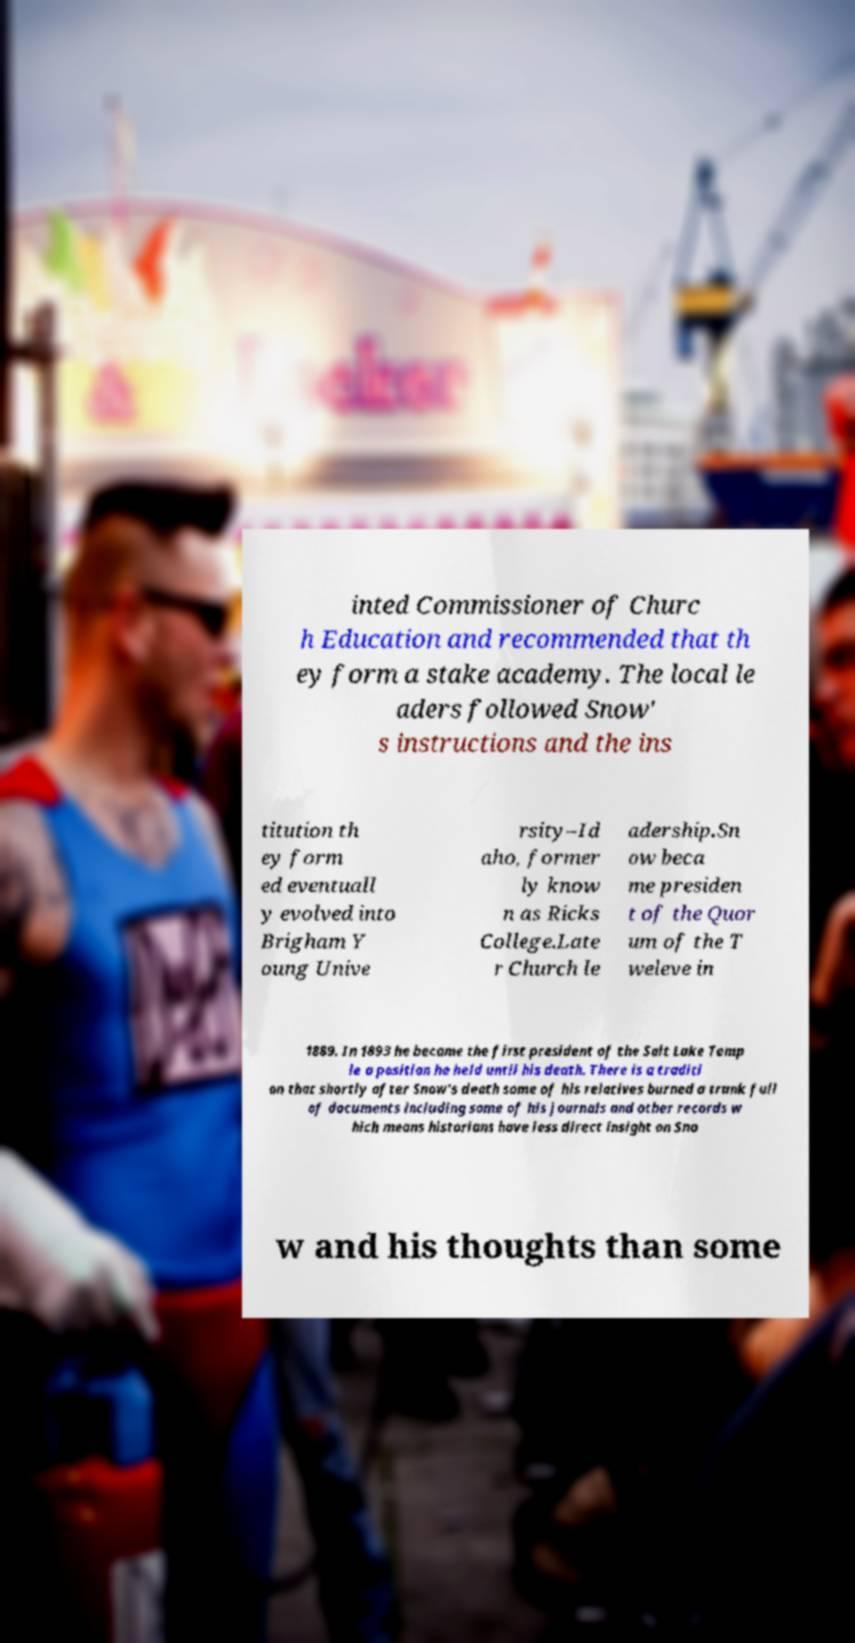Could you assist in decoding the text presented in this image and type it out clearly? inted Commissioner of Churc h Education and recommended that th ey form a stake academy. The local le aders followed Snow' s instructions and the ins titution th ey form ed eventuall y evolved into Brigham Y oung Unive rsity–Id aho, former ly know n as Ricks College.Late r Church le adership.Sn ow beca me presiden t of the Quor um of the T weleve in 1889. In 1893 he became the first president of the Salt Lake Temp le a position he held until his death. There is a traditi on that shortly after Snow's death some of his relatives burned a trunk full of documents including some of his journals and other records w hich means historians have less direct insight on Sno w and his thoughts than some 